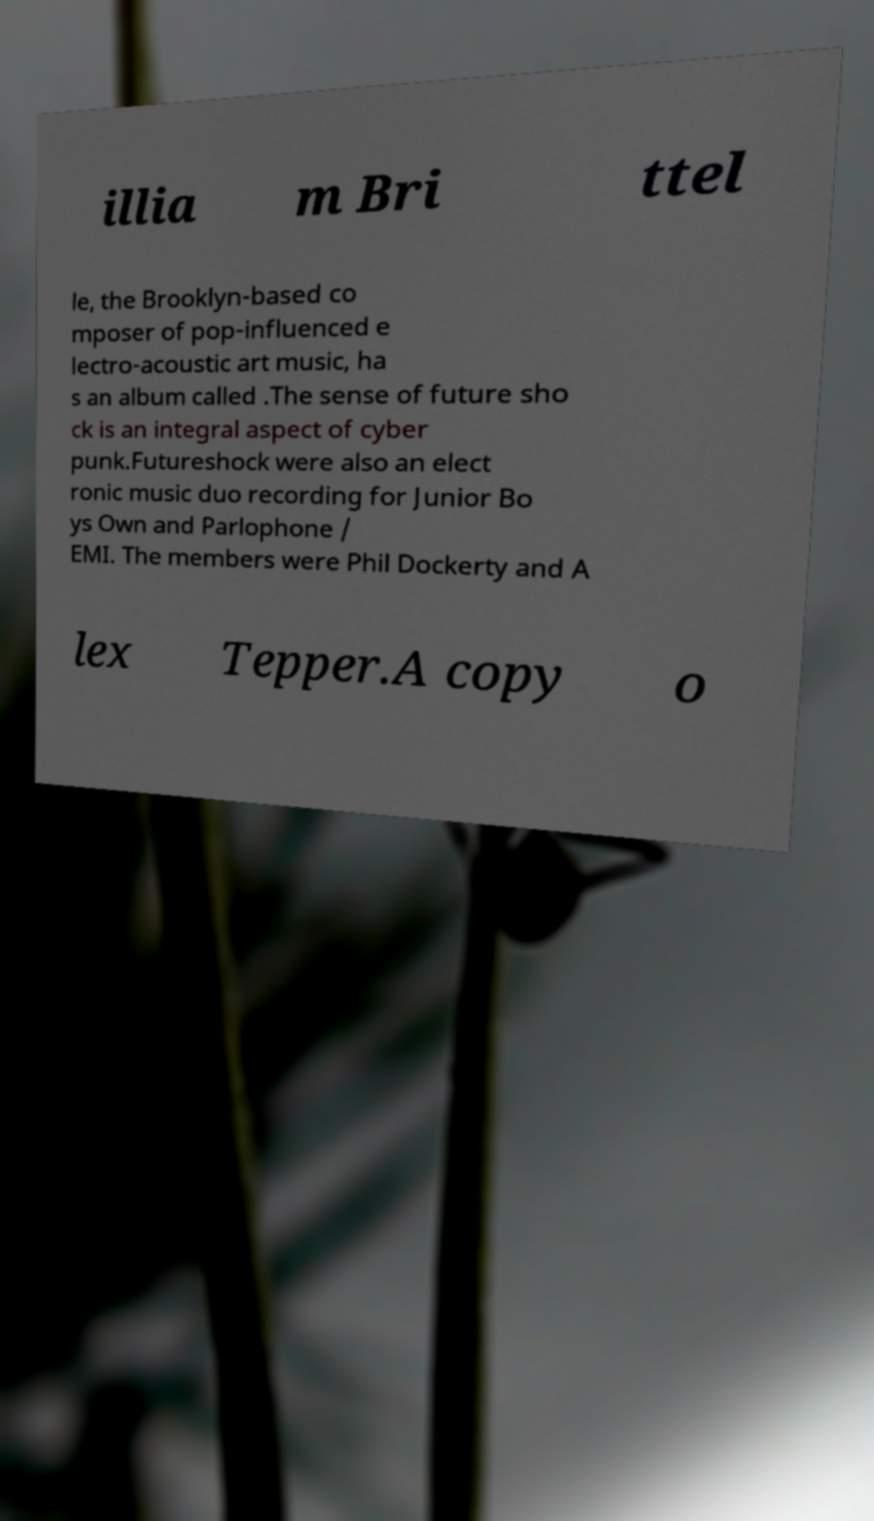Could you assist in decoding the text presented in this image and type it out clearly? illia m Bri ttel le, the Brooklyn-based co mposer of pop-influenced e lectro-acoustic art music, ha s an album called .The sense of future sho ck is an integral aspect of cyber punk.Futureshock were also an elect ronic music duo recording for Junior Bo ys Own and Parlophone / EMI. The members were Phil Dockerty and A lex Tepper.A copy o 